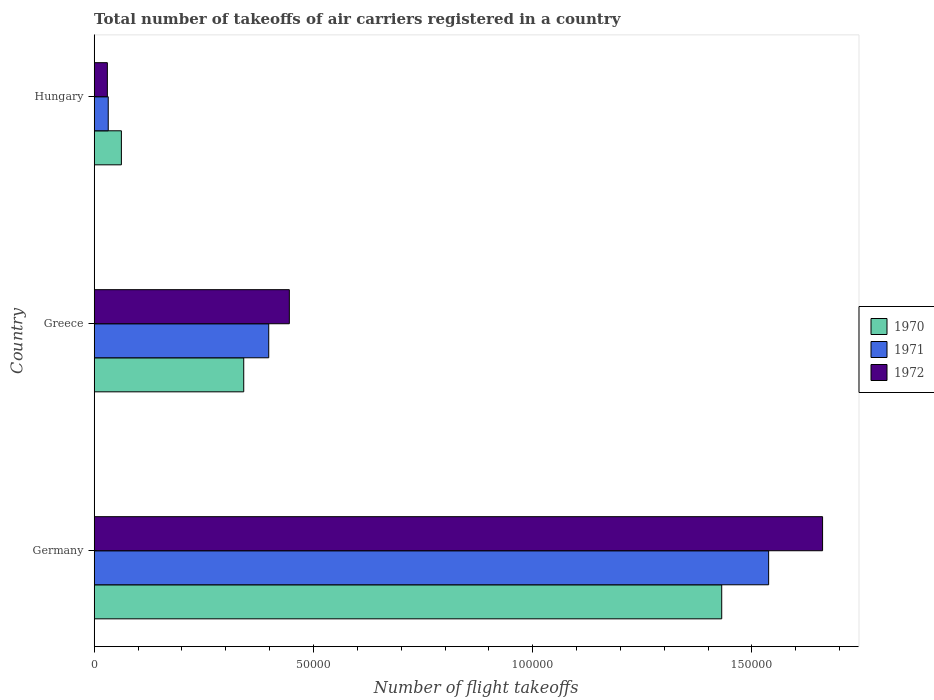How many different coloured bars are there?
Your response must be concise. 3. Are the number of bars on each tick of the Y-axis equal?
Make the answer very short. Yes. How many bars are there on the 3rd tick from the top?
Your answer should be compact. 3. What is the label of the 1st group of bars from the top?
Your answer should be compact. Hungary. What is the total number of flight takeoffs in 1970 in Greece?
Give a very brief answer. 3.41e+04. Across all countries, what is the maximum total number of flight takeoffs in 1972?
Provide a short and direct response. 1.66e+05. Across all countries, what is the minimum total number of flight takeoffs in 1970?
Provide a succinct answer. 6200. In which country was the total number of flight takeoffs in 1972 maximum?
Your response must be concise. Germany. In which country was the total number of flight takeoffs in 1970 minimum?
Provide a short and direct response. Hungary. What is the total total number of flight takeoffs in 1972 in the graph?
Your response must be concise. 2.14e+05. What is the difference between the total number of flight takeoffs in 1971 in Germany and that in Greece?
Make the answer very short. 1.14e+05. What is the difference between the total number of flight takeoffs in 1972 in Greece and the total number of flight takeoffs in 1970 in Hungary?
Provide a succinct answer. 3.83e+04. What is the average total number of flight takeoffs in 1971 per country?
Your response must be concise. 6.56e+04. What is the difference between the total number of flight takeoffs in 1970 and total number of flight takeoffs in 1972 in Germany?
Ensure brevity in your answer.  -2.30e+04. What is the ratio of the total number of flight takeoffs in 1971 in Germany to that in Hungary?
Make the answer very short. 48.06. What is the difference between the highest and the second highest total number of flight takeoffs in 1972?
Your response must be concise. 1.22e+05. What is the difference between the highest and the lowest total number of flight takeoffs in 1970?
Your response must be concise. 1.37e+05. Is the sum of the total number of flight takeoffs in 1972 in Germany and Greece greater than the maximum total number of flight takeoffs in 1971 across all countries?
Provide a succinct answer. Yes. What does the 2nd bar from the top in Hungary represents?
Ensure brevity in your answer.  1971. What does the 3rd bar from the bottom in Greece represents?
Give a very brief answer. 1972. Is it the case that in every country, the sum of the total number of flight takeoffs in 1971 and total number of flight takeoffs in 1972 is greater than the total number of flight takeoffs in 1970?
Provide a short and direct response. No. How many bars are there?
Give a very brief answer. 9. How many countries are there in the graph?
Keep it short and to the point. 3. Does the graph contain any zero values?
Provide a short and direct response. No. Does the graph contain grids?
Your response must be concise. No. How many legend labels are there?
Give a very brief answer. 3. How are the legend labels stacked?
Give a very brief answer. Vertical. What is the title of the graph?
Provide a succinct answer. Total number of takeoffs of air carriers registered in a country. What is the label or title of the X-axis?
Your answer should be very brief. Number of flight takeoffs. What is the label or title of the Y-axis?
Provide a short and direct response. Country. What is the Number of flight takeoffs of 1970 in Germany?
Your answer should be very brief. 1.43e+05. What is the Number of flight takeoffs of 1971 in Germany?
Offer a terse response. 1.54e+05. What is the Number of flight takeoffs of 1972 in Germany?
Your response must be concise. 1.66e+05. What is the Number of flight takeoffs in 1970 in Greece?
Make the answer very short. 3.41e+04. What is the Number of flight takeoffs of 1971 in Greece?
Give a very brief answer. 3.98e+04. What is the Number of flight takeoffs in 1972 in Greece?
Provide a short and direct response. 4.45e+04. What is the Number of flight takeoffs of 1970 in Hungary?
Give a very brief answer. 6200. What is the Number of flight takeoffs in 1971 in Hungary?
Your answer should be compact. 3200. What is the Number of flight takeoffs in 1972 in Hungary?
Make the answer very short. 3000. Across all countries, what is the maximum Number of flight takeoffs in 1970?
Offer a terse response. 1.43e+05. Across all countries, what is the maximum Number of flight takeoffs in 1971?
Give a very brief answer. 1.54e+05. Across all countries, what is the maximum Number of flight takeoffs of 1972?
Keep it short and to the point. 1.66e+05. Across all countries, what is the minimum Number of flight takeoffs in 1970?
Your response must be concise. 6200. Across all countries, what is the minimum Number of flight takeoffs of 1971?
Offer a very short reply. 3200. Across all countries, what is the minimum Number of flight takeoffs in 1972?
Give a very brief answer. 3000. What is the total Number of flight takeoffs of 1970 in the graph?
Your answer should be very brief. 1.83e+05. What is the total Number of flight takeoffs of 1971 in the graph?
Your answer should be very brief. 1.97e+05. What is the total Number of flight takeoffs in 1972 in the graph?
Your answer should be very brief. 2.14e+05. What is the difference between the Number of flight takeoffs in 1970 in Germany and that in Greece?
Provide a succinct answer. 1.09e+05. What is the difference between the Number of flight takeoffs in 1971 in Germany and that in Greece?
Provide a short and direct response. 1.14e+05. What is the difference between the Number of flight takeoffs in 1972 in Germany and that in Greece?
Give a very brief answer. 1.22e+05. What is the difference between the Number of flight takeoffs of 1970 in Germany and that in Hungary?
Your response must be concise. 1.37e+05. What is the difference between the Number of flight takeoffs of 1971 in Germany and that in Hungary?
Offer a very short reply. 1.51e+05. What is the difference between the Number of flight takeoffs of 1972 in Germany and that in Hungary?
Offer a terse response. 1.63e+05. What is the difference between the Number of flight takeoffs of 1970 in Greece and that in Hungary?
Your answer should be very brief. 2.79e+04. What is the difference between the Number of flight takeoffs in 1971 in Greece and that in Hungary?
Give a very brief answer. 3.66e+04. What is the difference between the Number of flight takeoffs in 1972 in Greece and that in Hungary?
Make the answer very short. 4.15e+04. What is the difference between the Number of flight takeoffs in 1970 in Germany and the Number of flight takeoffs in 1971 in Greece?
Offer a very short reply. 1.03e+05. What is the difference between the Number of flight takeoffs in 1970 in Germany and the Number of flight takeoffs in 1972 in Greece?
Offer a terse response. 9.86e+04. What is the difference between the Number of flight takeoffs of 1971 in Germany and the Number of flight takeoffs of 1972 in Greece?
Provide a succinct answer. 1.09e+05. What is the difference between the Number of flight takeoffs in 1970 in Germany and the Number of flight takeoffs in 1971 in Hungary?
Give a very brief answer. 1.40e+05. What is the difference between the Number of flight takeoffs in 1970 in Germany and the Number of flight takeoffs in 1972 in Hungary?
Provide a succinct answer. 1.40e+05. What is the difference between the Number of flight takeoffs in 1971 in Germany and the Number of flight takeoffs in 1972 in Hungary?
Ensure brevity in your answer.  1.51e+05. What is the difference between the Number of flight takeoffs in 1970 in Greece and the Number of flight takeoffs in 1971 in Hungary?
Provide a succinct answer. 3.09e+04. What is the difference between the Number of flight takeoffs in 1970 in Greece and the Number of flight takeoffs in 1972 in Hungary?
Ensure brevity in your answer.  3.11e+04. What is the difference between the Number of flight takeoffs in 1971 in Greece and the Number of flight takeoffs in 1972 in Hungary?
Provide a short and direct response. 3.68e+04. What is the average Number of flight takeoffs of 1970 per country?
Give a very brief answer. 6.11e+04. What is the average Number of flight takeoffs of 1971 per country?
Your answer should be compact. 6.56e+04. What is the average Number of flight takeoffs of 1972 per country?
Offer a terse response. 7.12e+04. What is the difference between the Number of flight takeoffs in 1970 and Number of flight takeoffs in 1971 in Germany?
Provide a succinct answer. -1.07e+04. What is the difference between the Number of flight takeoffs in 1970 and Number of flight takeoffs in 1972 in Germany?
Provide a short and direct response. -2.30e+04. What is the difference between the Number of flight takeoffs of 1971 and Number of flight takeoffs of 1972 in Germany?
Your answer should be compact. -1.23e+04. What is the difference between the Number of flight takeoffs of 1970 and Number of flight takeoffs of 1971 in Greece?
Your answer should be very brief. -5700. What is the difference between the Number of flight takeoffs of 1970 and Number of flight takeoffs of 1972 in Greece?
Provide a succinct answer. -1.04e+04. What is the difference between the Number of flight takeoffs of 1971 and Number of flight takeoffs of 1972 in Greece?
Your response must be concise. -4700. What is the difference between the Number of flight takeoffs of 1970 and Number of flight takeoffs of 1971 in Hungary?
Keep it short and to the point. 3000. What is the difference between the Number of flight takeoffs of 1970 and Number of flight takeoffs of 1972 in Hungary?
Provide a succinct answer. 3200. What is the difference between the Number of flight takeoffs in 1971 and Number of flight takeoffs in 1972 in Hungary?
Provide a short and direct response. 200. What is the ratio of the Number of flight takeoffs in 1970 in Germany to that in Greece?
Your answer should be very brief. 4.2. What is the ratio of the Number of flight takeoffs of 1971 in Germany to that in Greece?
Your answer should be compact. 3.86. What is the ratio of the Number of flight takeoffs of 1972 in Germany to that in Greece?
Your answer should be compact. 3.73. What is the ratio of the Number of flight takeoffs in 1970 in Germany to that in Hungary?
Your answer should be compact. 23.08. What is the ratio of the Number of flight takeoffs in 1971 in Germany to that in Hungary?
Your response must be concise. 48.06. What is the ratio of the Number of flight takeoffs of 1972 in Germany to that in Hungary?
Your response must be concise. 55.37. What is the ratio of the Number of flight takeoffs in 1970 in Greece to that in Hungary?
Provide a succinct answer. 5.5. What is the ratio of the Number of flight takeoffs in 1971 in Greece to that in Hungary?
Give a very brief answer. 12.44. What is the ratio of the Number of flight takeoffs of 1972 in Greece to that in Hungary?
Make the answer very short. 14.83. What is the difference between the highest and the second highest Number of flight takeoffs of 1970?
Offer a very short reply. 1.09e+05. What is the difference between the highest and the second highest Number of flight takeoffs in 1971?
Offer a very short reply. 1.14e+05. What is the difference between the highest and the second highest Number of flight takeoffs of 1972?
Offer a terse response. 1.22e+05. What is the difference between the highest and the lowest Number of flight takeoffs of 1970?
Your answer should be compact. 1.37e+05. What is the difference between the highest and the lowest Number of flight takeoffs of 1971?
Provide a short and direct response. 1.51e+05. What is the difference between the highest and the lowest Number of flight takeoffs in 1972?
Give a very brief answer. 1.63e+05. 